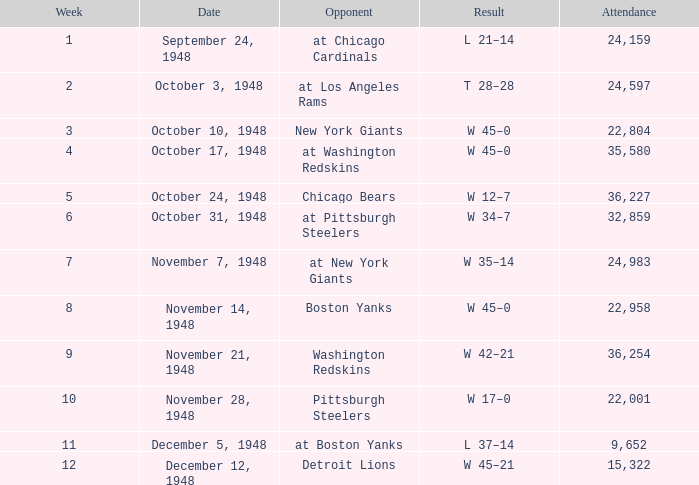What is the lowest value for Week, when the Attendance is greater than 22,958, and when the Opponent is At Chicago Cardinals? 1.0. 